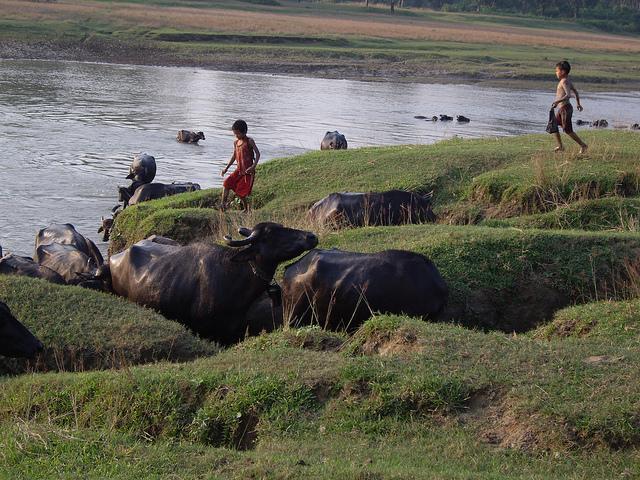How many children are in the photo?
Give a very brief answer. 2. How many cows are in the picture?
Give a very brief answer. 3. 